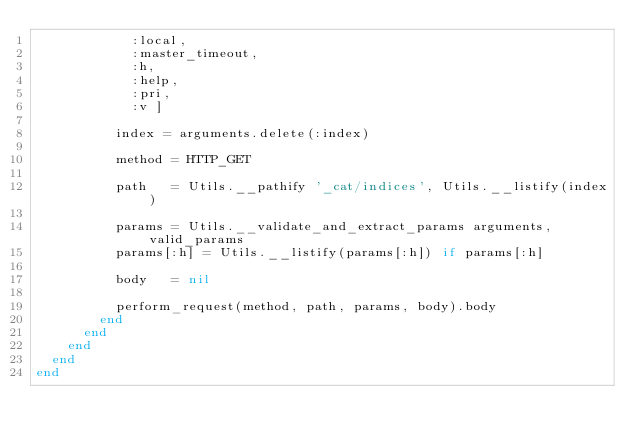<code> <loc_0><loc_0><loc_500><loc_500><_Ruby_>            :local,
            :master_timeout,
            :h,
            :help,
            :pri,
            :v ]

          index = arguments.delete(:index)

          method = HTTP_GET

          path   = Utils.__pathify '_cat/indices', Utils.__listify(index)

          params = Utils.__validate_and_extract_params arguments, valid_params
          params[:h] = Utils.__listify(params[:h]) if params[:h]

          body   = nil

          perform_request(method, path, params, body).body
        end
      end
    end
  end
end
</code> 